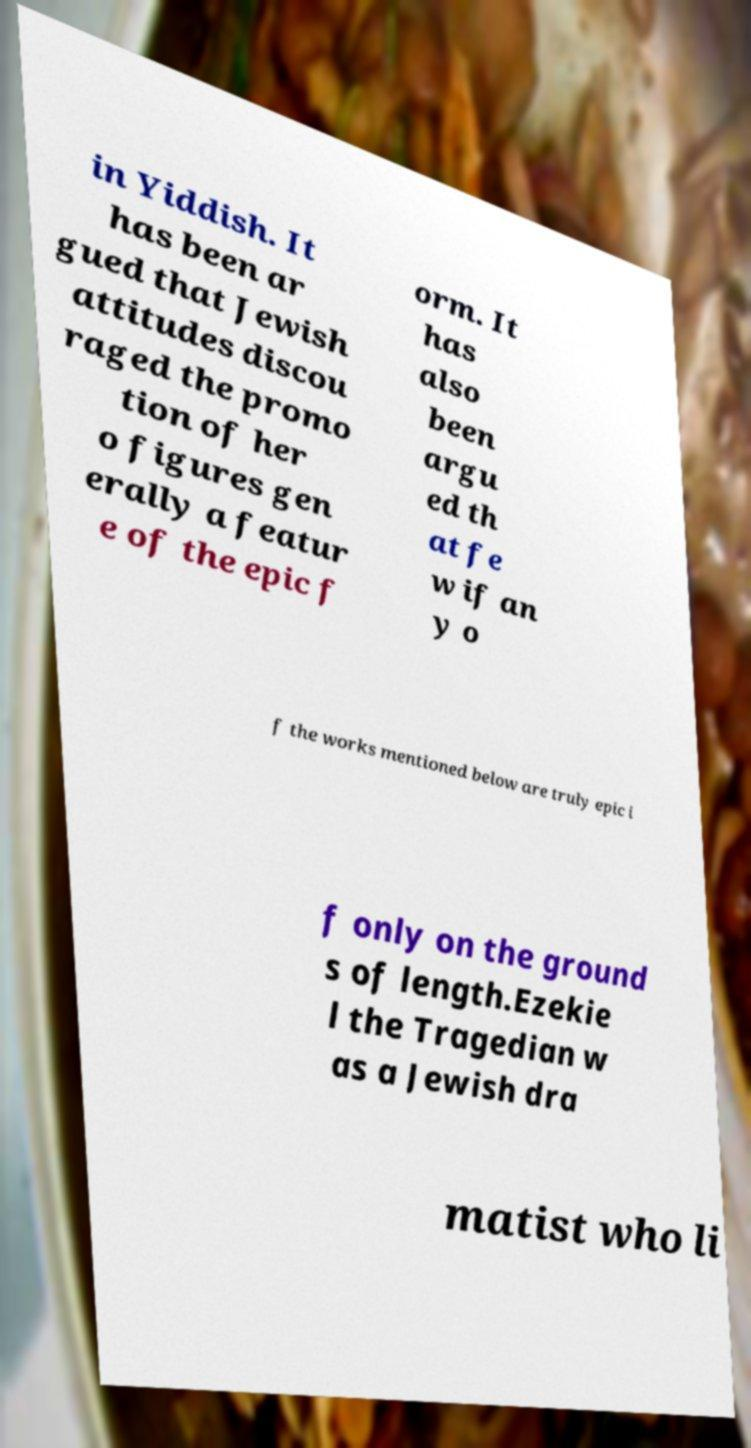There's text embedded in this image that I need extracted. Can you transcribe it verbatim? in Yiddish. It has been ar gued that Jewish attitudes discou raged the promo tion of her o figures gen erally a featur e of the epic f orm. It has also been argu ed th at fe w if an y o f the works mentioned below are truly epic i f only on the ground s of length.Ezekie l the Tragedian w as a Jewish dra matist who li 